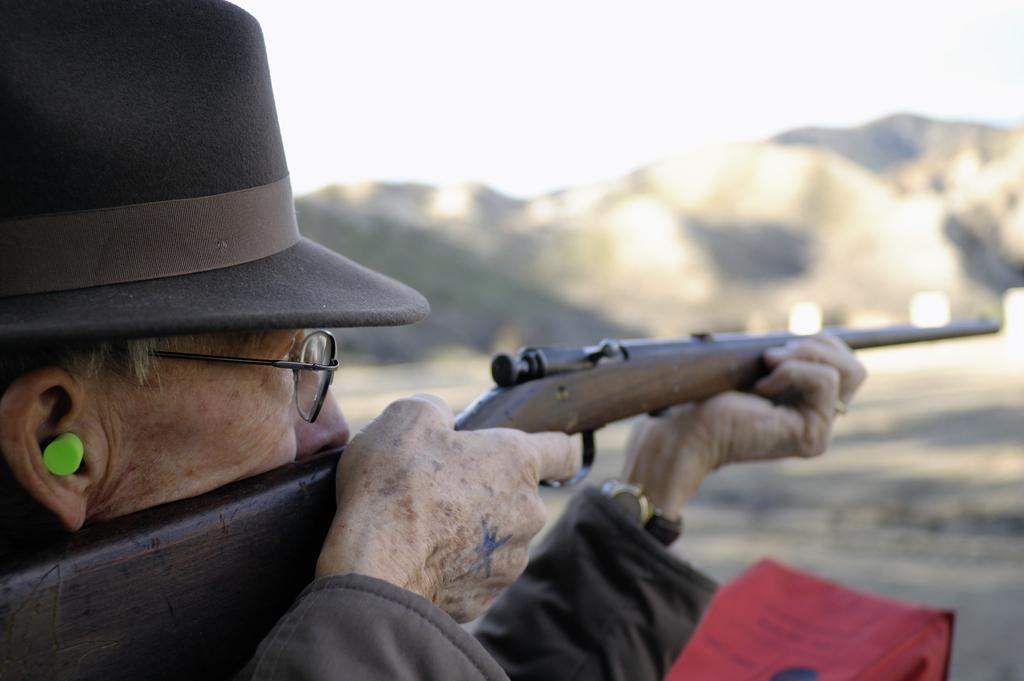Describe this image in one or two sentences. Here we can see a person holding a gun with his hands and he has spectacles. In the background we can see mountain and sky. 